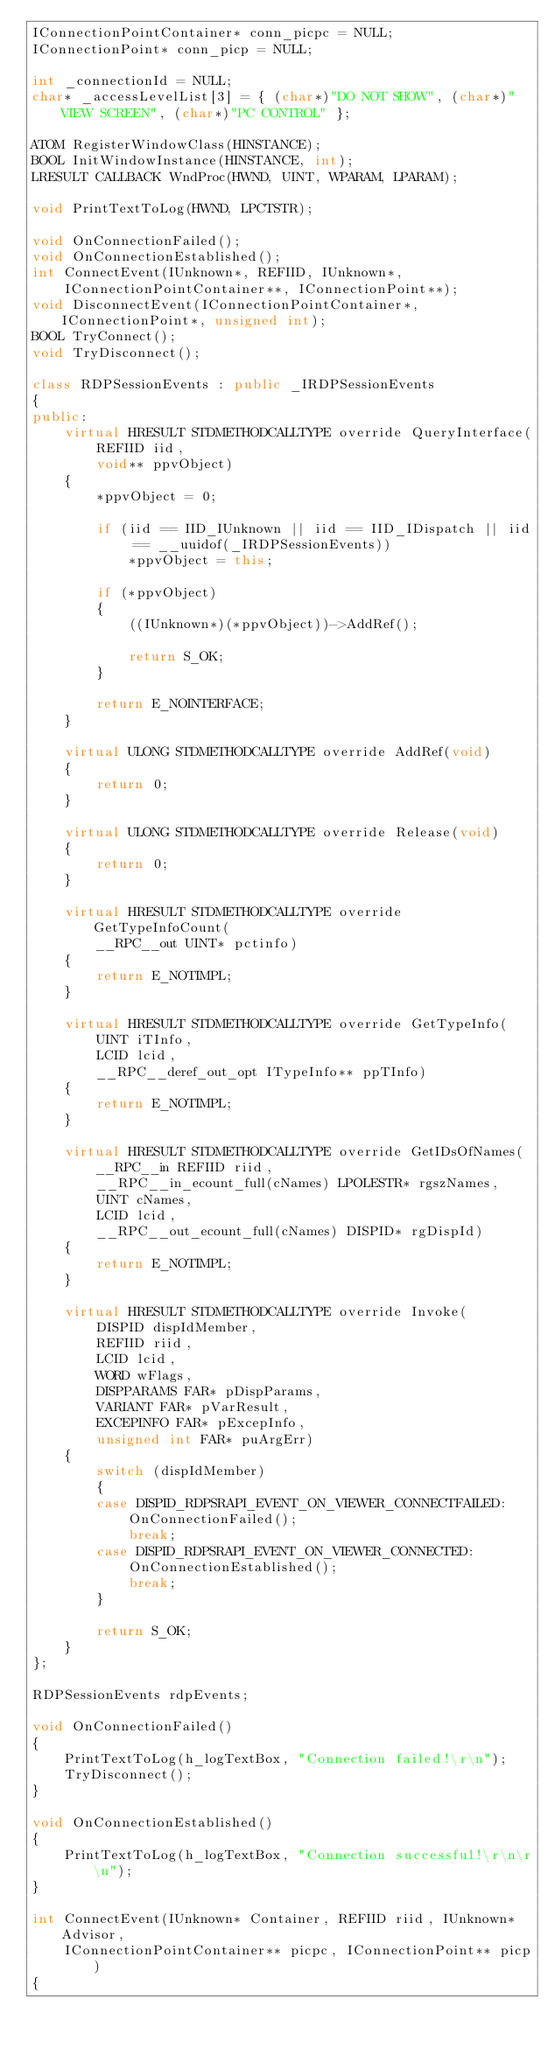<code> <loc_0><loc_0><loc_500><loc_500><_C++_>IConnectionPointContainer* conn_picpc = NULL;
IConnectionPoint* conn_picp = NULL;

int _connectionId = NULL;
char* _accessLevelList[3] = { (char*)"DO NOT SHOW", (char*)"VIEW SCREEN", (char*)"PC CONTROL" };

ATOM RegisterWindowClass(HINSTANCE);
BOOL InitWindowInstance(HINSTANCE, int);
LRESULT CALLBACK WndProc(HWND, UINT, WPARAM, LPARAM);

void PrintTextToLog(HWND, LPCTSTR);

void OnConnectionFailed();
void OnConnectionEstablished();
int ConnectEvent(IUnknown*, REFIID, IUnknown*,
    IConnectionPointContainer**, IConnectionPoint**);
void DisconnectEvent(IConnectionPointContainer*, IConnectionPoint*, unsigned int);
BOOL TryConnect();
void TryDisconnect();

class RDPSessionEvents : public _IRDPSessionEvents
{
public:
    virtual HRESULT STDMETHODCALLTYPE override QueryInterface(
        REFIID iid,
        void** ppvObject)
    {
        *ppvObject = 0;

        if (iid == IID_IUnknown || iid == IID_IDispatch || iid == __uuidof(_IRDPSessionEvents))
            *ppvObject = this;

        if (*ppvObject)
        {
            ((IUnknown*)(*ppvObject))->AddRef();

            return S_OK;
        }

        return E_NOINTERFACE;
    }

    virtual ULONG STDMETHODCALLTYPE override AddRef(void)
    {
        return 0;
    }

    virtual ULONG STDMETHODCALLTYPE override Release(void)
    {
        return 0;
    }

    virtual HRESULT STDMETHODCALLTYPE override GetTypeInfoCount(
        __RPC__out UINT* pctinfo)
    {
        return E_NOTIMPL;
    }

    virtual HRESULT STDMETHODCALLTYPE override GetTypeInfo(
        UINT iTInfo,
        LCID lcid,
        __RPC__deref_out_opt ITypeInfo** ppTInfo)
    {
        return E_NOTIMPL;
    }

    virtual HRESULT STDMETHODCALLTYPE override GetIDsOfNames(
        __RPC__in REFIID riid,
        __RPC__in_ecount_full(cNames) LPOLESTR* rgszNames,
        UINT cNames,
        LCID lcid,
        __RPC__out_ecount_full(cNames) DISPID* rgDispId)
    {
        return E_NOTIMPL;
    }

    virtual HRESULT STDMETHODCALLTYPE override Invoke(
        DISPID dispIdMember,
        REFIID riid,
        LCID lcid,
        WORD wFlags,
        DISPPARAMS FAR* pDispParams,
        VARIANT FAR* pVarResult,
        EXCEPINFO FAR* pExcepInfo,
        unsigned int FAR* puArgErr)
    {
        switch (dispIdMember) 
        {
        case DISPID_RDPSRAPI_EVENT_ON_VIEWER_CONNECTFAILED:
            OnConnectionFailed();
            break;
        case DISPID_RDPSRAPI_EVENT_ON_VIEWER_CONNECTED:
            OnConnectionEstablished();
            break;
        }

        return S_OK;
    }
};

RDPSessionEvents rdpEvents;

void OnConnectionFailed()
{
    PrintTextToLog(h_logTextBox, "Connection failed!\r\n");
    TryDisconnect();
}

void OnConnectionEstablished() 
{
    PrintTextToLog(h_logTextBox, "Connection successful!\r\n\r\n");
}

int ConnectEvent(IUnknown* Container, REFIID riid, IUnknown* Advisor,
    IConnectionPointContainer** picpc, IConnectionPoint** picp)
{</code> 